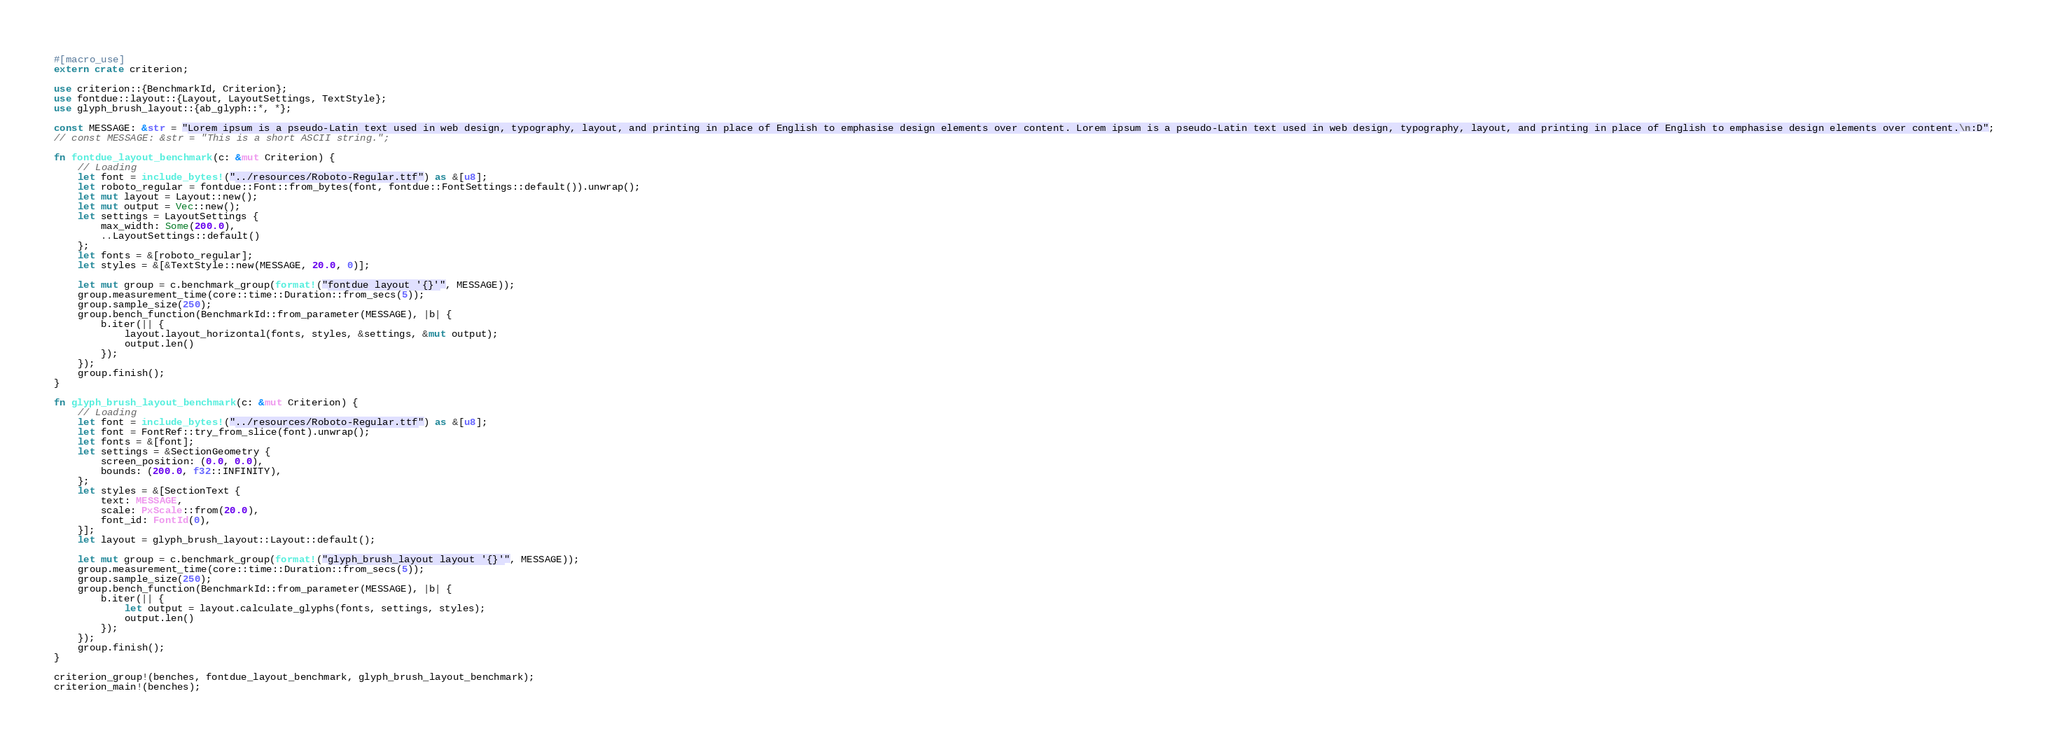Convert code to text. <code><loc_0><loc_0><loc_500><loc_500><_Rust_>#[macro_use]
extern crate criterion;

use criterion::{BenchmarkId, Criterion};
use fontdue::layout::{Layout, LayoutSettings, TextStyle};
use glyph_brush_layout::{ab_glyph::*, *};

const MESSAGE: &str = "Lorem ipsum is a pseudo-Latin text used in web design, typography, layout, and printing in place of English to emphasise design elements over content. Lorem ipsum is a pseudo-Latin text used in web design, typography, layout, and printing in place of English to emphasise design elements over content.\n:D";
// const MESSAGE: &str = "This is a short ASCII string.";

fn fontdue_layout_benchmark(c: &mut Criterion) {
    // Loading
    let font = include_bytes!("../resources/Roboto-Regular.ttf") as &[u8];
    let roboto_regular = fontdue::Font::from_bytes(font, fontdue::FontSettings::default()).unwrap();
    let mut layout = Layout::new();
    let mut output = Vec::new();
    let settings = LayoutSettings {
        max_width: Some(200.0),
        ..LayoutSettings::default()
    };
    let fonts = &[roboto_regular];
    let styles = &[&TextStyle::new(MESSAGE, 20.0, 0)];

    let mut group = c.benchmark_group(format!("fontdue layout '{}'", MESSAGE));
    group.measurement_time(core::time::Duration::from_secs(5));
    group.sample_size(250);
    group.bench_function(BenchmarkId::from_parameter(MESSAGE), |b| {
        b.iter(|| {
            layout.layout_horizontal(fonts, styles, &settings, &mut output);
            output.len()
        });
    });
    group.finish();
}

fn glyph_brush_layout_benchmark(c: &mut Criterion) {
    // Loading
    let font = include_bytes!("../resources/Roboto-Regular.ttf") as &[u8];
    let font = FontRef::try_from_slice(font).unwrap();
    let fonts = &[font];
    let settings = &SectionGeometry {
        screen_position: (0.0, 0.0),
        bounds: (200.0, f32::INFINITY),
    };
    let styles = &[SectionText {
        text: MESSAGE,
        scale: PxScale::from(20.0),
        font_id: FontId(0),
    }];
    let layout = glyph_brush_layout::Layout::default();

    let mut group = c.benchmark_group(format!("glyph_brush_layout layout '{}'", MESSAGE));
    group.measurement_time(core::time::Duration::from_secs(5));
    group.sample_size(250);
    group.bench_function(BenchmarkId::from_parameter(MESSAGE), |b| {
        b.iter(|| {
            let output = layout.calculate_glyphs(fonts, settings, styles);
            output.len()
        });
    });
    group.finish();
}

criterion_group!(benches, fontdue_layout_benchmark, glyph_brush_layout_benchmark);
criterion_main!(benches);
</code> 